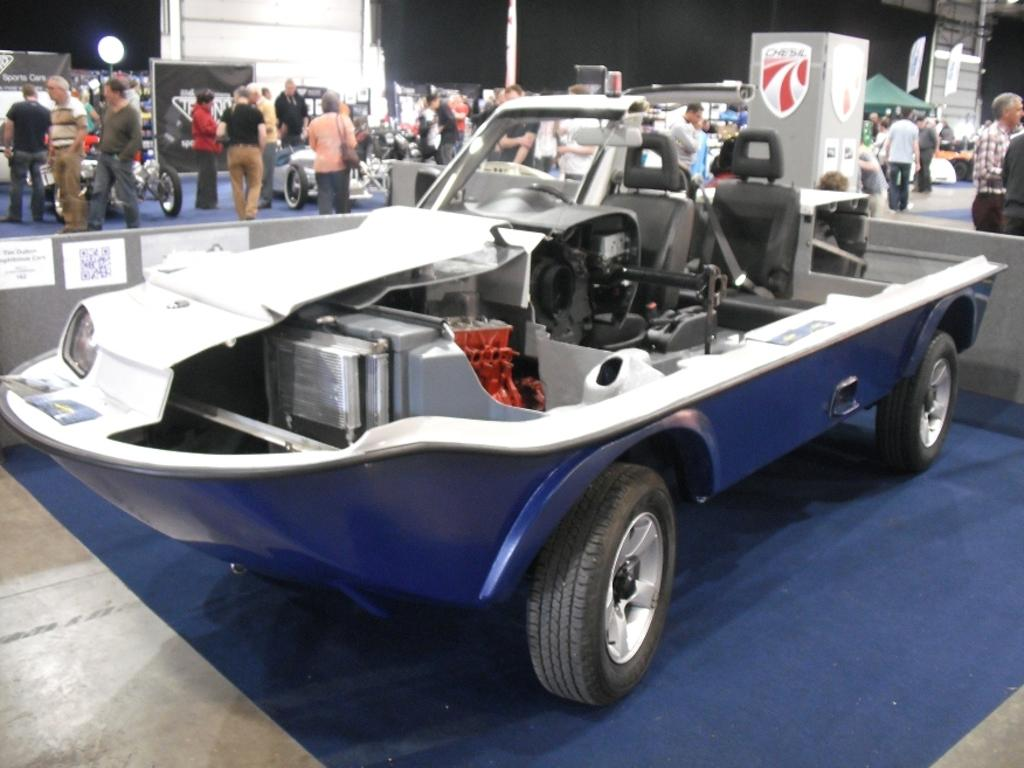What types of objects are present in the image? There are vehicles and persons in the image. Can you describe the car in the image? There is a car on a carpet in the middle of the image. What mathematical division is being performed by the persons in the image? There is no indication in the image that any mathematical division is being performed by the persons. 